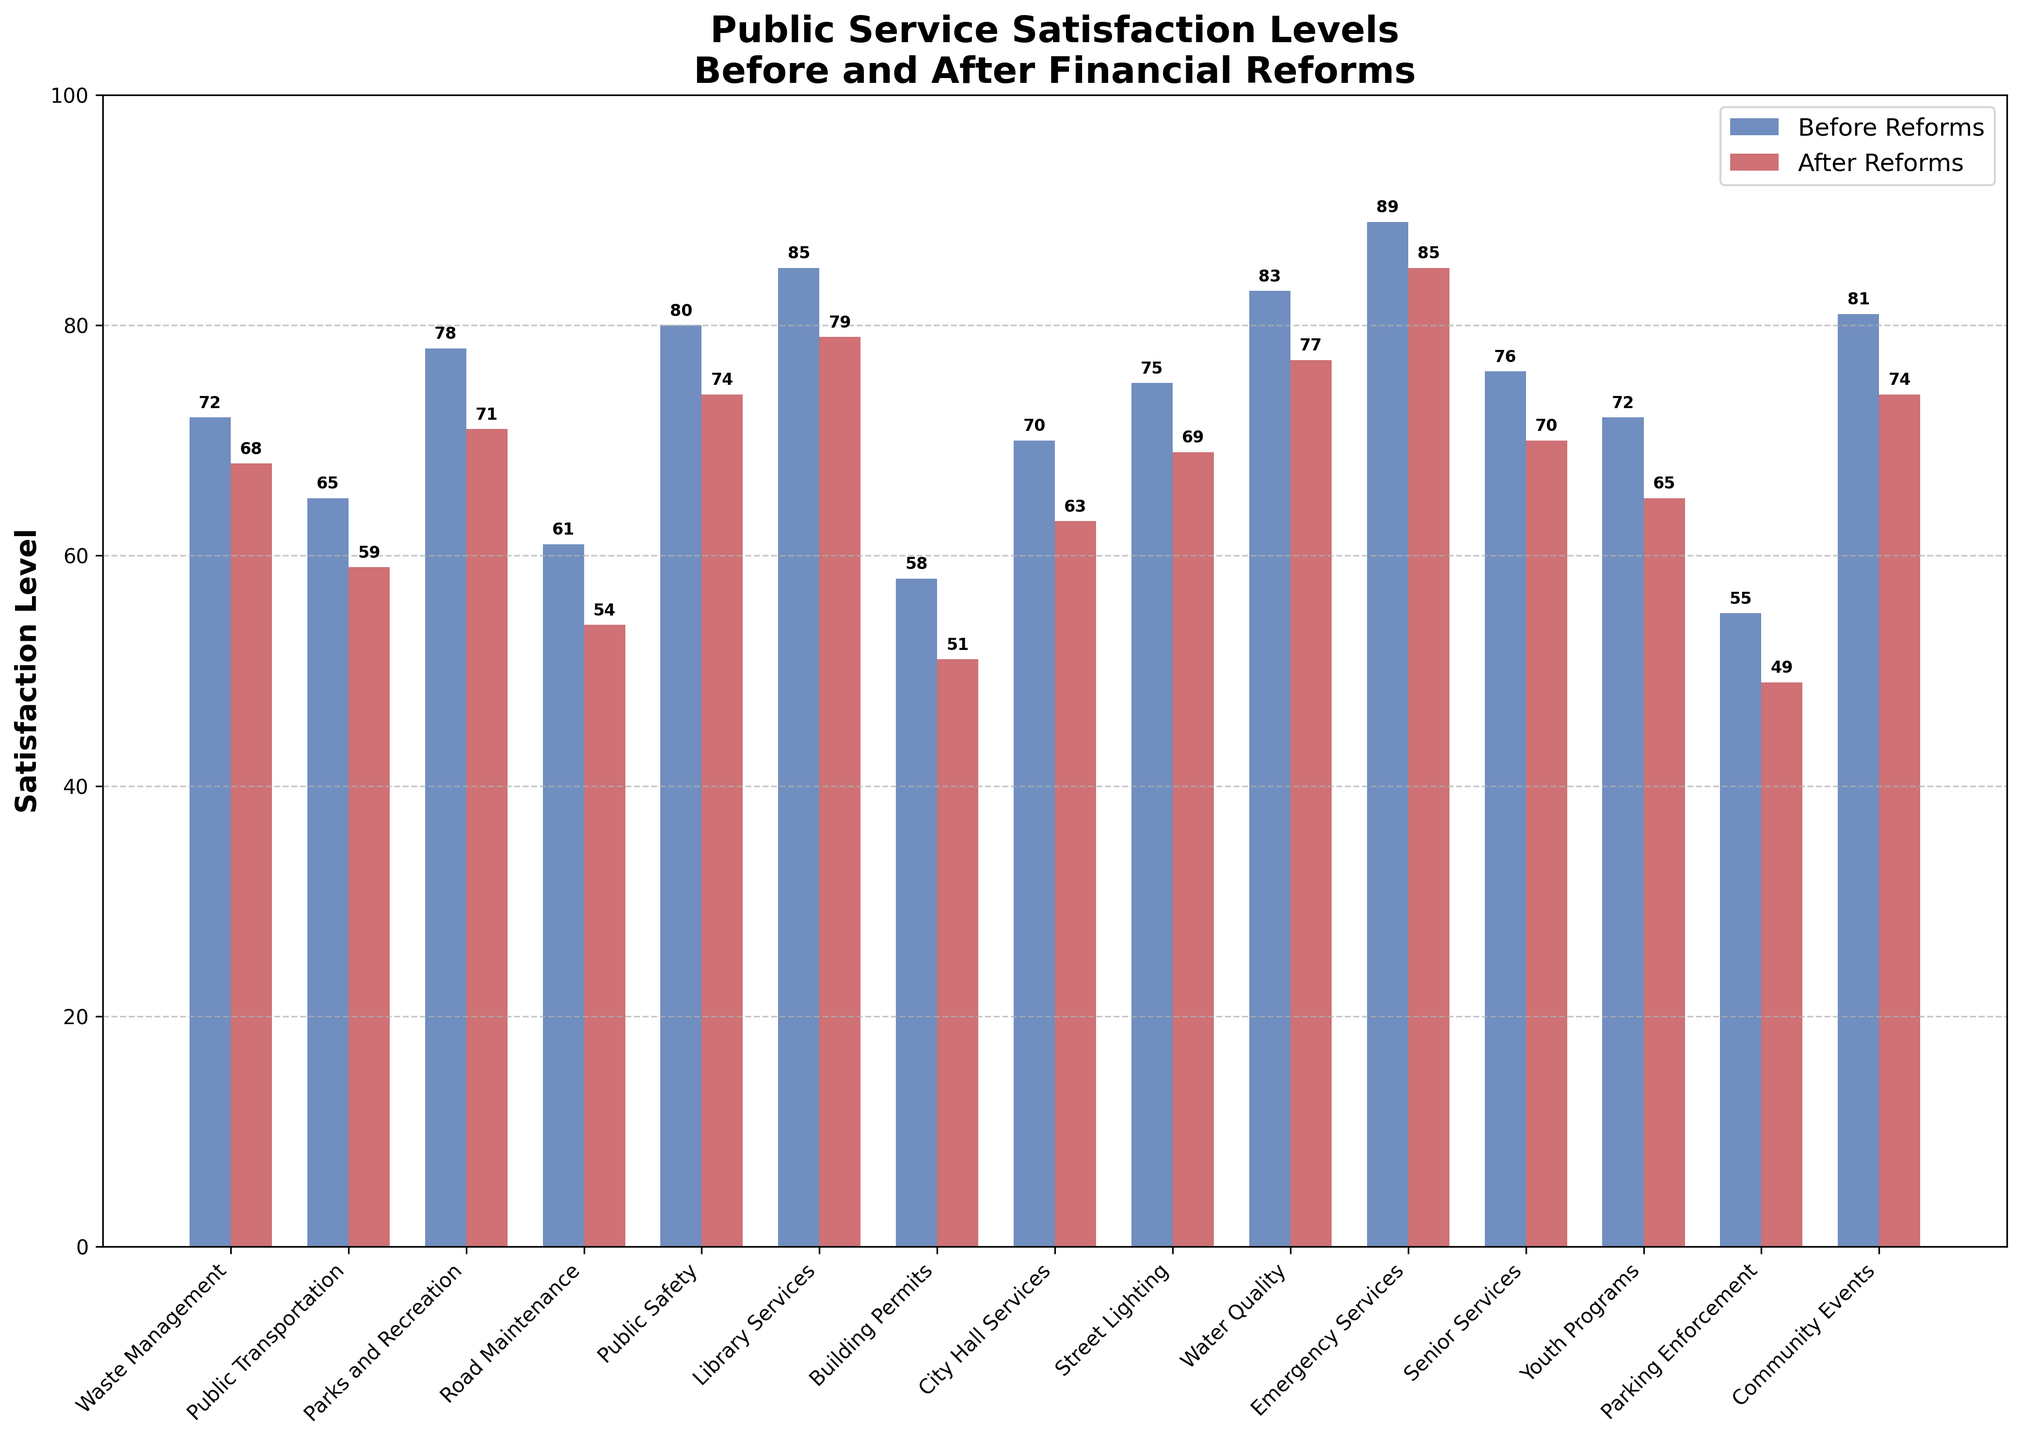What service had the highest satisfaction level before the reforms? The bar representing "Emergency Services" is the tallest among the blue bars (Before Reforms), indicating the highest satisfaction level before the reforms.
Answer: Emergency Services Which service experienced the greatest drop in satisfaction levels after the reforms? By comparing the height differences of the blue (Before Reforms) and red (After Reforms) bars, "Public Transportation" shows a drop from 65 to 59, a decrease of 6 points.
Answer: Public Transportation What is the average satisfaction level for Public Services before and after the reforms? First, sum the satisfaction levels before and after the reforms and then divide by the number of services (15). (72+65+78+61+80+85+58+70+75+83+89+76+72+55+81) = 1080 before, (68+59+71+54+74+79+51+63+69+77+85+70+65+49+74) = 958 after. The averages are 1080/15 = 72 and 958/15 = 63.87.
Answer: 72 before, 63.87 after Which services did the satisfaction level remain over 70 after the reforms? By checking the red bars (After Reforms), we see "Emergency Services" (85), "Library Services" (79), "Public Safety" (74), "Community Events" (74), and "Water Quality" (77) remain over 70.
Answer: Emergency Services, Library Services, Public Safety, Community Events, Water Quality What is the difference in satisfaction levels for "Public Safety" before and after the reforms? The satisfaction level for "Public Safety" before reforms is 80 and after reforms is 74. The difference is 80 - 74 = 6.
Answer: 6 Which services had a satisfaction level below 60 after the reforms? Checking the red bars (After Reforms), "Public Transportation" (59), "Road Maintenance" (54), "Building Permits" (51), "Youth Programs" (65), and "Parking Enforcement" (49) had levels below 60.
Answer: Public Transportation, Road Maintenance, Building Permits, Youth Programs, Parking Enforcement How did the satisfaction levels for "Library Services" change after the reforms? The satisfaction level for "Library Services" before the reforms is 85 and after reforms is 79. The change is a decrease of 6 points.
Answer: Decreased by 6 Which service has the smallest satisfaction level difference before and after reforms? By comparing the height differences for each service, "Emergency Services" has the smallest difference with a drop from 89 to 85, a difference of 4 points.
Answer: Emergency Services 